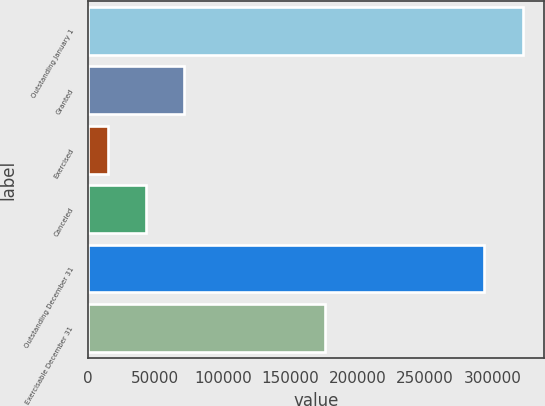<chart> <loc_0><loc_0><loc_500><loc_500><bar_chart><fcel>Outstanding January 1<fcel>Granted<fcel>Exercised<fcel>Canceled<fcel>Outstanding December 31<fcel>Exercisable December 31<nl><fcel>322442<fcel>71405.4<fcel>14574<fcel>42989.7<fcel>294026<fcel>176163<nl></chart> 